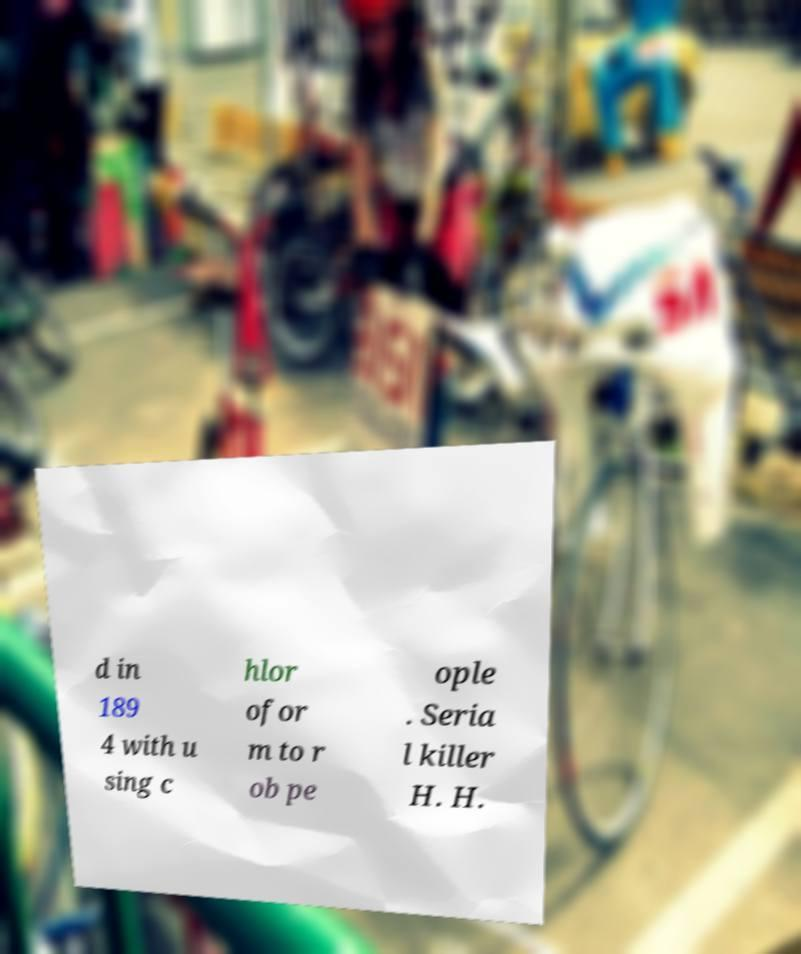Please identify and transcribe the text found in this image. d in 189 4 with u sing c hlor ofor m to r ob pe ople . Seria l killer H. H. 